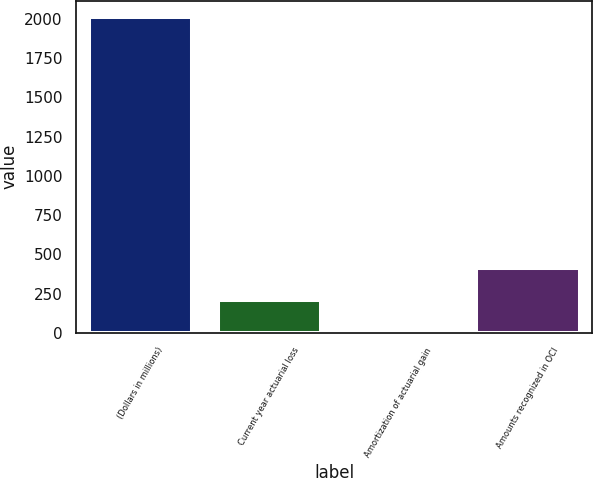Convert chart to OTSL. <chart><loc_0><loc_0><loc_500><loc_500><bar_chart><fcel>(Dollars in millions)<fcel>Current year actuarial loss<fcel>Amortization of actuarial gain<fcel>Amounts recognized in OCI<nl><fcel>2015<fcel>211<fcel>6<fcel>411.9<nl></chart> 